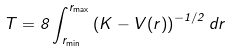<formula> <loc_0><loc_0><loc_500><loc_500>T = 8 \int _ { r _ { \min } } ^ { r _ { \max } } \left ( K - V ( r ) \right ) ^ { - 1 / 2 } d r</formula> 